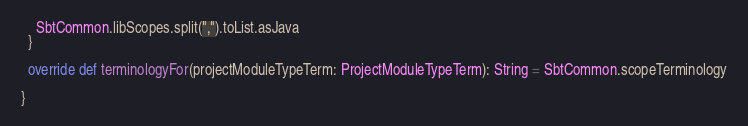Convert code to text. <code><loc_0><loc_0><loc_500><loc_500><_Scala_>    SbtCommon.libScopes.split(",").toList.asJava
  }

  override def terminologyFor(projectModuleTypeTerm: ProjectModuleTypeTerm): String = SbtCommon.scopeTerminology

}
</code> 